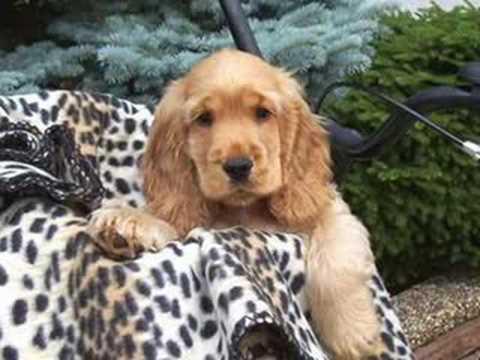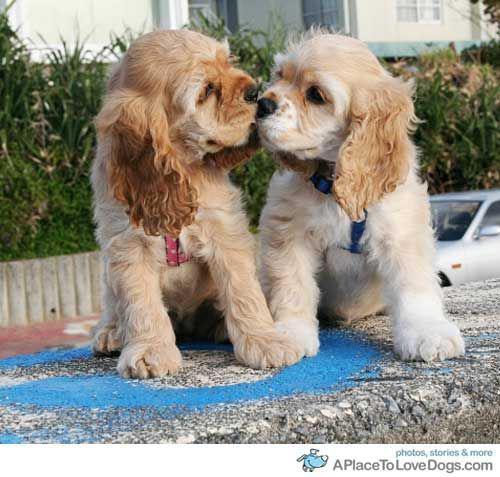The first image is the image on the left, the second image is the image on the right. Assess this claim about the two images: "The image on the right contains exactly two dogs.". Correct or not? Answer yes or no. Yes. The first image is the image on the left, the second image is the image on the right. Given the left and right images, does the statement "Each image contains at least two cocker spaniels, and at least one image shows cocker spaniels sitting upright and looking upward." hold true? Answer yes or no. No. 